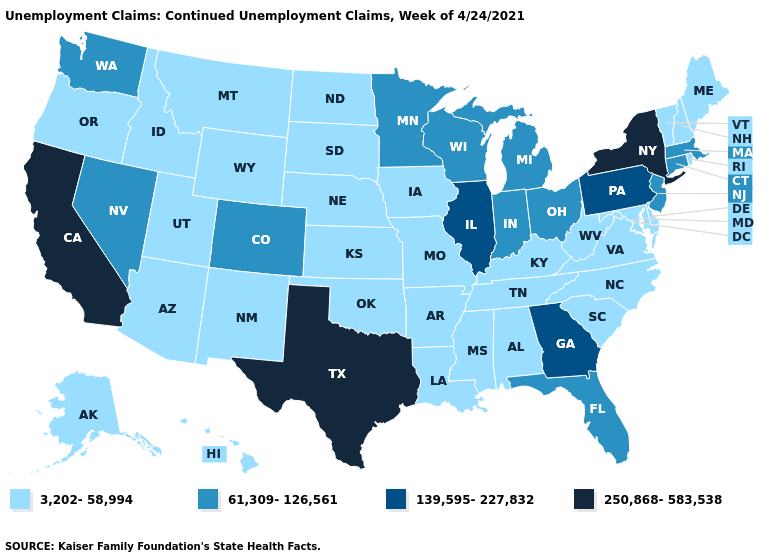What is the lowest value in states that border Kansas?
Short answer required. 3,202-58,994. Name the states that have a value in the range 139,595-227,832?
Give a very brief answer. Georgia, Illinois, Pennsylvania. Name the states that have a value in the range 250,868-583,538?
Give a very brief answer. California, New York, Texas. Which states hav the highest value in the South?
Give a very brief answer. Texas. Is the legend a continuous bar?
Give a very brief answer. No. Name the states that have a value in the range 61,309-126,561?
Be succinct. Colorado, Connecticut, Florida, Indiana, Massachusetts, Michigan, Minnesota, Nevada, New Jersey, Ohio, Washington, Wisconsin. What is the value of New Mexico?
Quick response, please. 3,202-58,994. Name the states that have a value in the range 61,309-126,561?
Concise answer only. Colorado, Connecticut, Florida, Indiana, Massachusetts, Michigan, Minnesota, Nevada, New Jersey, Ohio, Washington, Wisconsin. Does Nebraska have a lower value than Connecticut?
Give a very brief answer. Yes. Does Maryland have the lowest value in the USA?
Keep it brief. Yes. Name the states that have a value in the range 61,309-126,561?
Write a very short answer. Colorado, Connecticut, Florida, Indiana, Massachusetts, Michigan, Minnesota, Nevada, New Jersey, Ohio, Washington, Wisconsin. Which states have the highest value in the USA?
Quick response, please. California, New York, Texas. Name the states that have a value in the range 139,595-227,832?
Short answer required. Georgia, Illinois, Pennsylvania. Does California have the highest value in the USA?
Write a very short answer. Yes. Is the legend a continuous bar?
Give a very brief answer. No. 